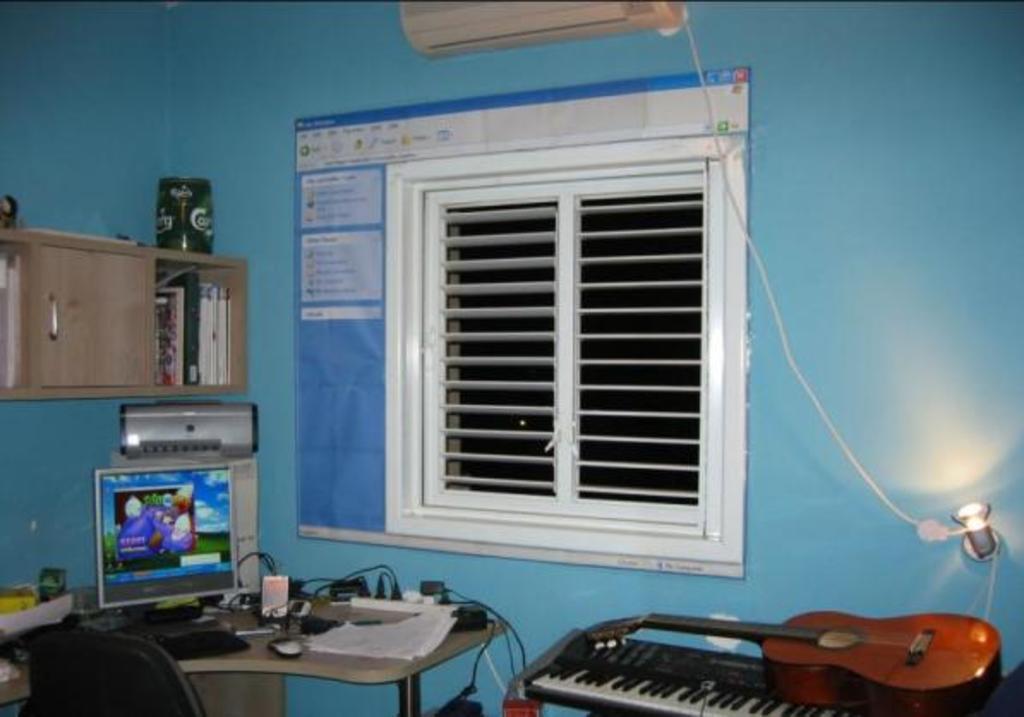Describe this image in one or two sentences. There is a computer on table with piano and guitar on other side and window on wall with bookshelf on top. 